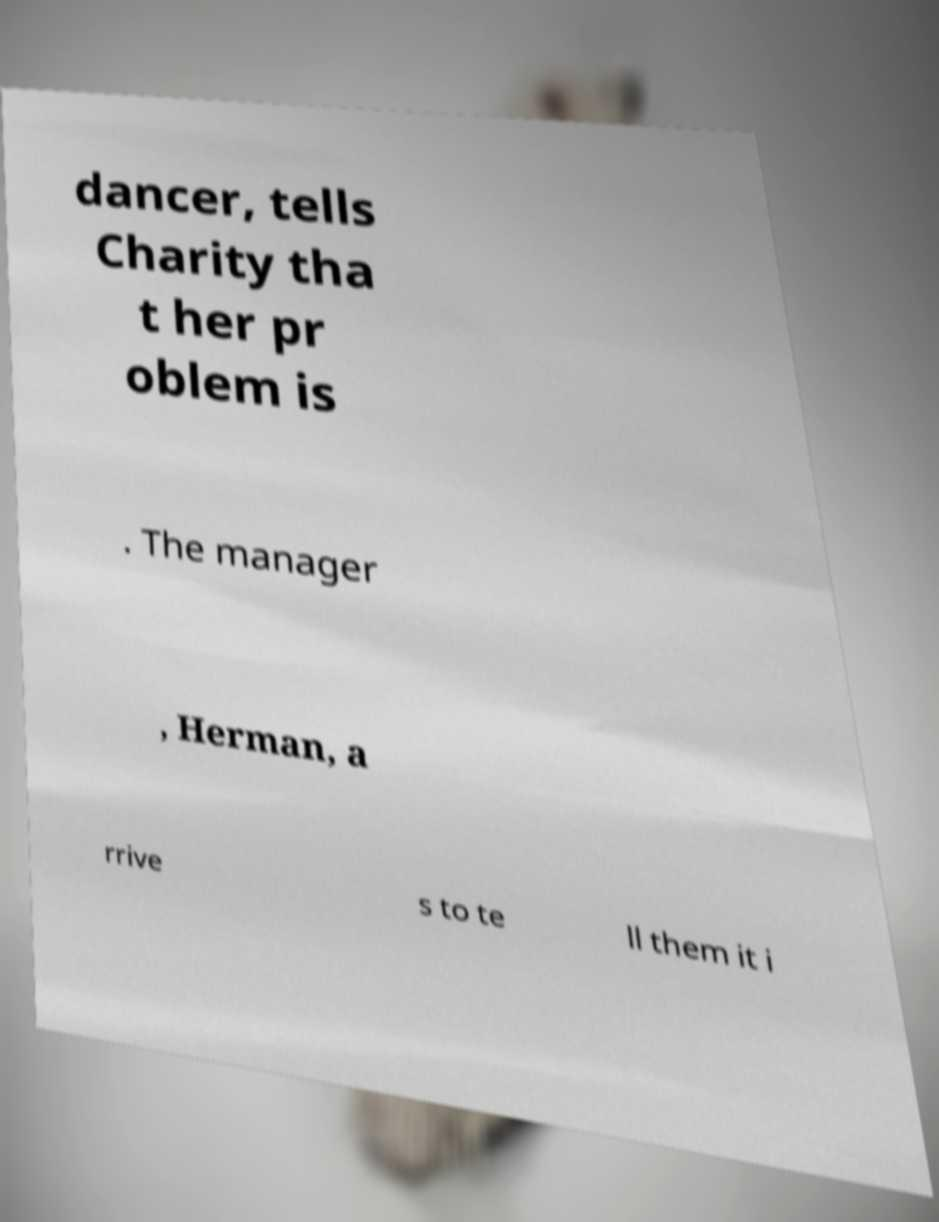Please identify and transcribe the text found in this image. dancer, tells Charity tha t her pr oblem is . The manager , Herman, a rrive s to te ll them it i 